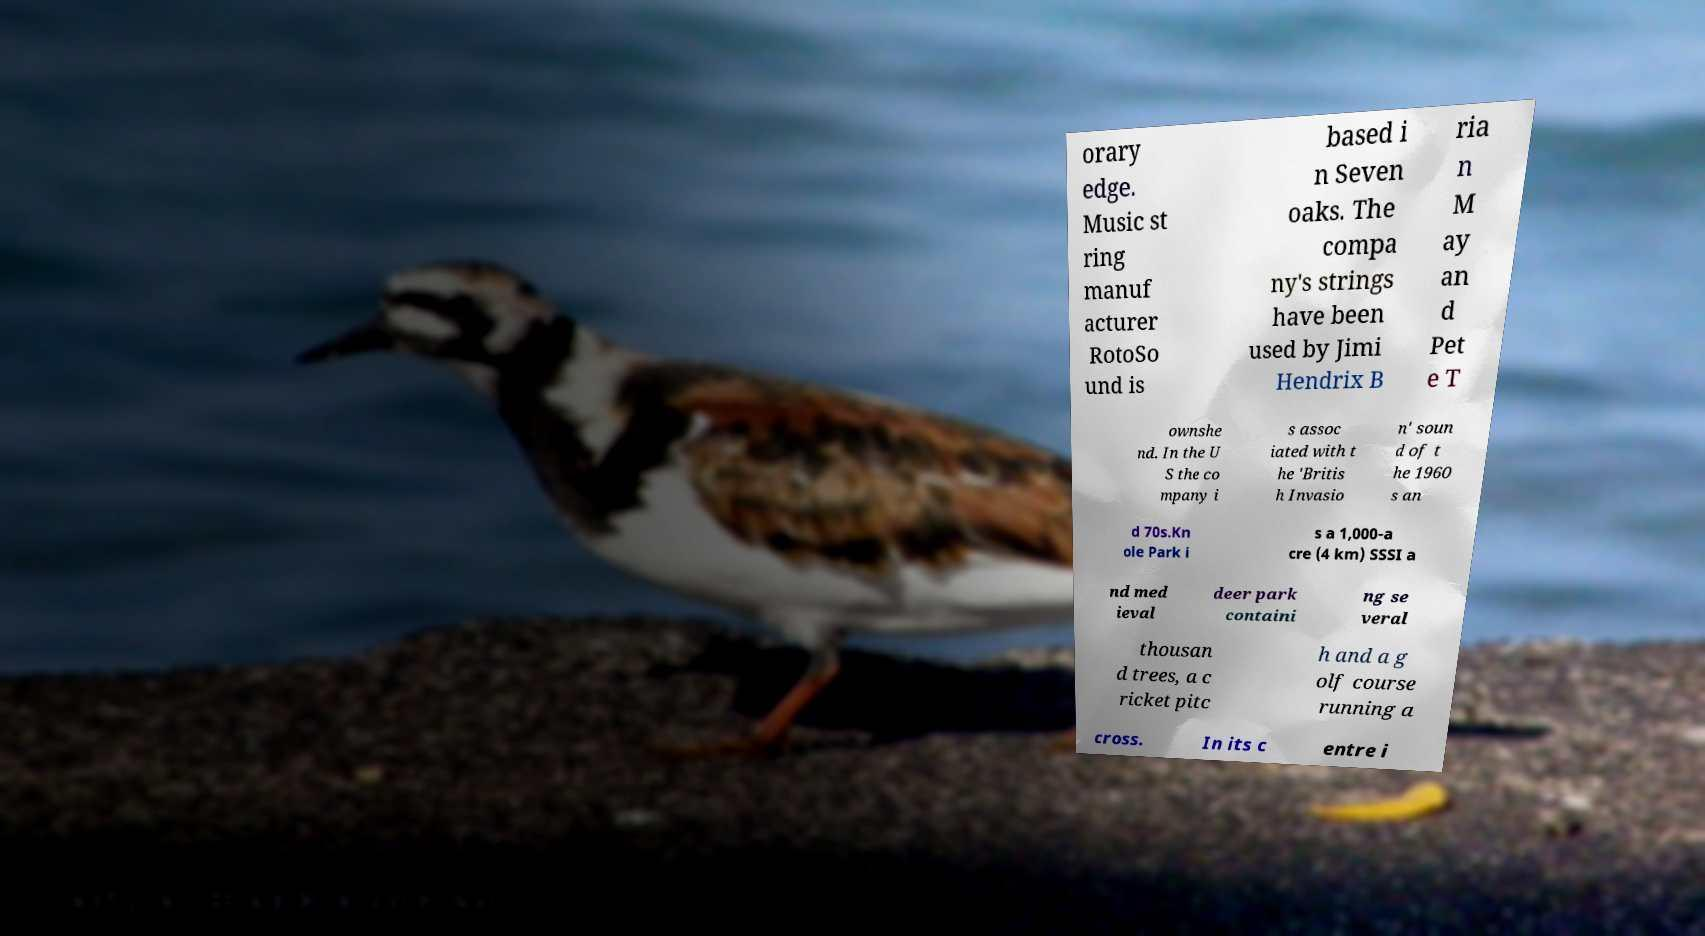Could you extract and type out the text from this image? orary edge. Music st ring manuf acturer RotoSo und is based i n Seven oaks. The compa ny's strings have been used by Jimi Hendrix B ria n M ay an d Pet e T ownshe nd. In the U S the co mpany i s assoc iated with t he 'Britis h Invasio n' soun d of t he 1960 s an d 70s.Kn ole Park i s a 1,000-a cre (4 km) SSSI a nd med ieval deer park containi ng se veral thousan d trees, a c ricket pitc h and a g olf course running a cross. In its c entre i 